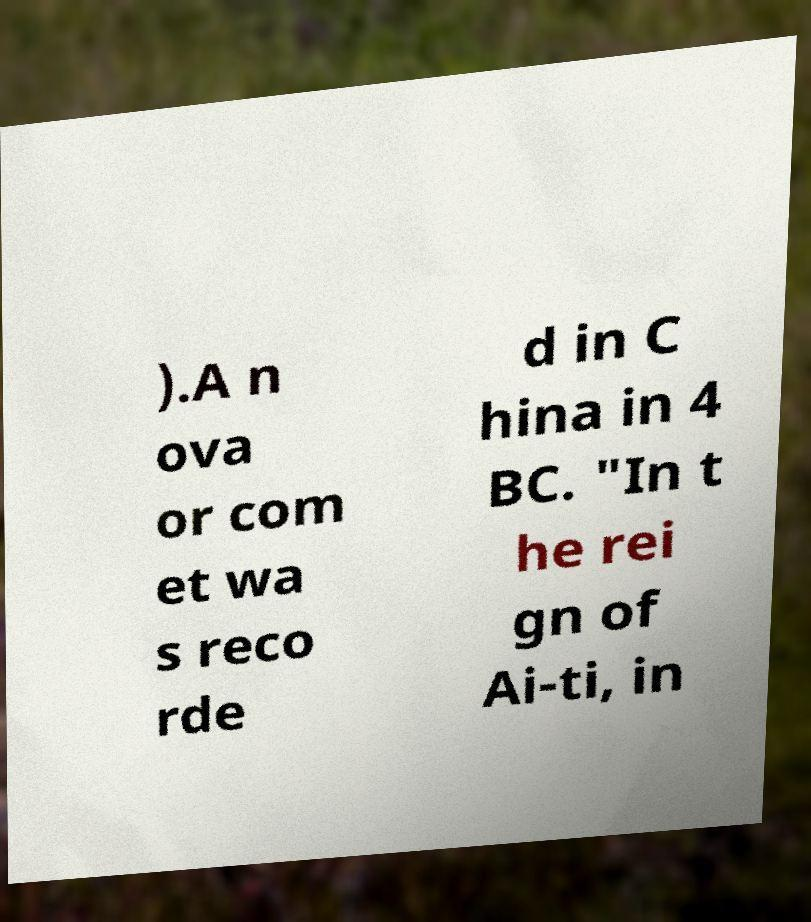I need the written content from this picture converted into text. Can you do that? ).A n ova or com et wa s reco rde d in C hina in 4 BC. "In t he rei gn of Ai-ti, in 